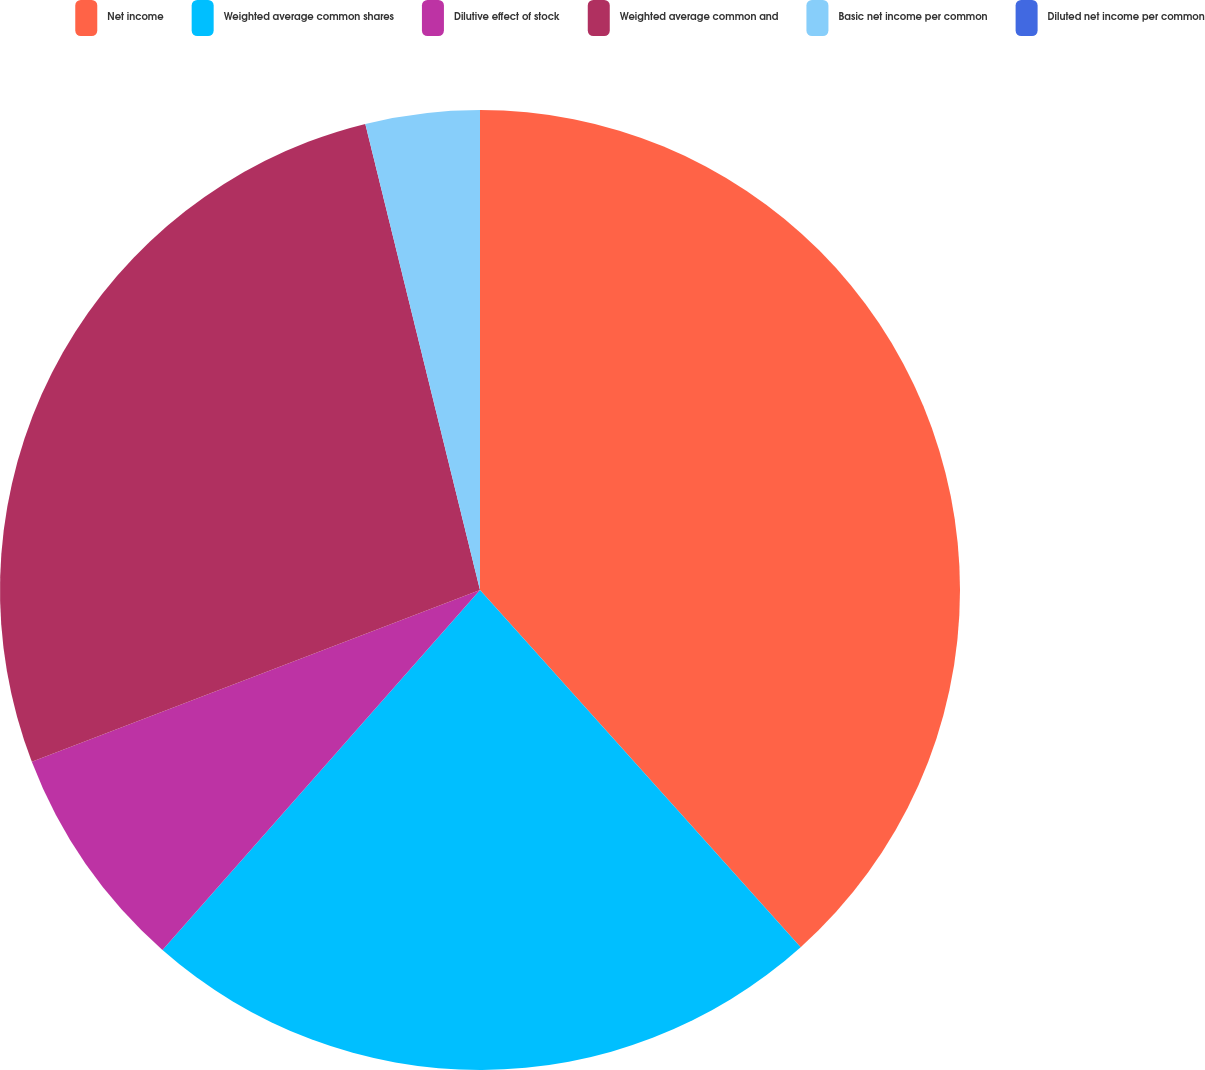Convert chart. <chart><loc_0><loc_0><loc_500><loc_500><pie_chart><fcel>Net income<fcel>Weighted average common shares<fcel>Dilutive effect of stock<fcel>Weighted average common and<fcel>Basic net income per common<fcel>Diluted net income per common<nl><fcel>38.36%<fcel>23.15%<fcel>7.67%<fcel>26.99%<fcel>3.84%<fcel>0.0%<nl></chart> 